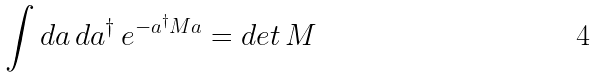Convert formula to latex. <formula><loc_0><loc_0><loc_500><loc_500>\int d a \, d a ^ { \dagger } \, e ^ { - a ^ { \dagger } M a } = d e t \, M</formula> 